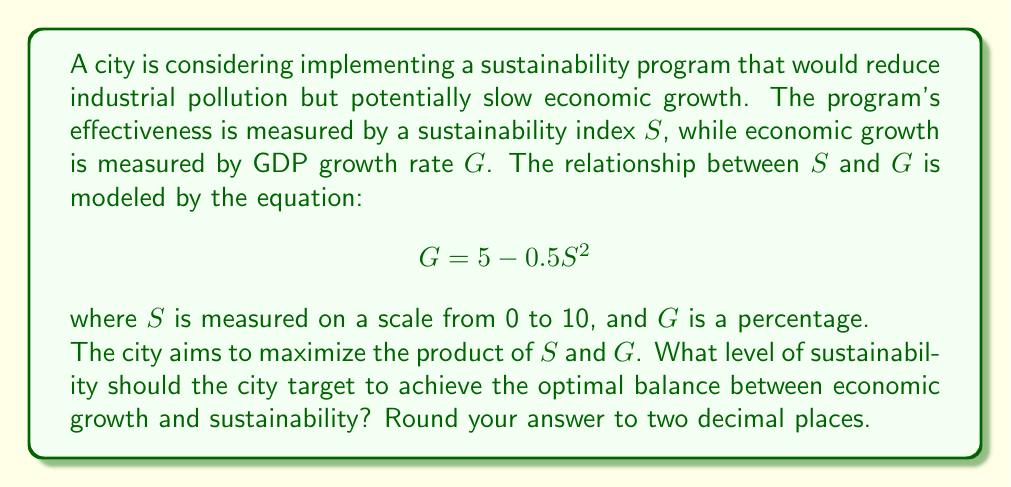Provide a solution to this math problem. To solve this problem, we need to find the maximum value of the product of $S$ and $G$. Let's call this product $P$.

1) Express $P$ in terms of $S$:
   $$P = S \cdot G = S(5 - 0.5S^2)$$

2) Expand the equation:
   $$P = 5S - 0.5S^3$$

3) To find the maximum value of $P$, we need to find where its derivative equals zero:
   $$\frac{dP}{dS} = 5 - 1.5S^2$$

4) Set the derivative to zero and solve for $S$:
   $$5 - 1.5S^2 = 0$$
   $$1.5S^2 = 5$$
   $$S^2 = \frac{10}{3}$$
   $$S = \sqrt{\frac{10}{3}} \approx 1.83$$

5) To confirm this is a maximum (not a minimum), we can check the second derivative:
   $$\frac{d^2P}{dS^2} = -3S$$
   At $S = \sqrt{\frac{10}{3}}$, this is negative, confirming a maximum.

6) Round the result to two decimal places: 1.83

This value of $S$ represents the optimal balance between sustainability and economic growth according to the given model.
Answer: 1.83 